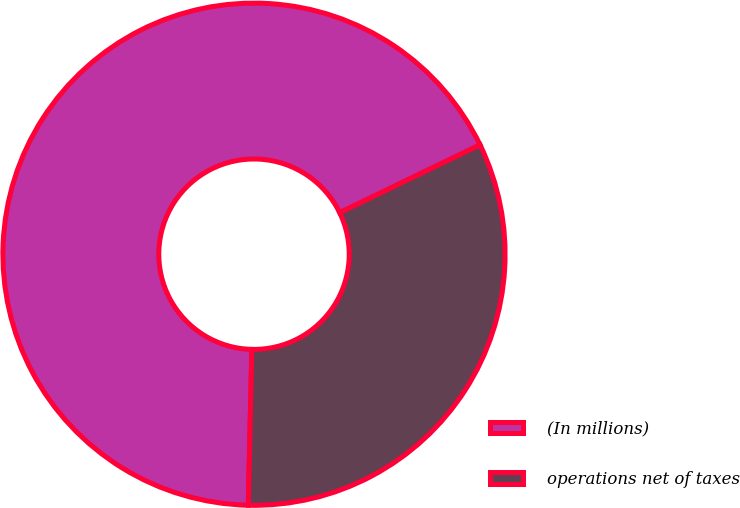<chart> <loc_0><loc_0><loc_500><loc_500><pie_chart><fcel>(In millions)<fcel>operations net of taxes<nl><fcel>67.47%<fcel>32.53%<nl></chart> 